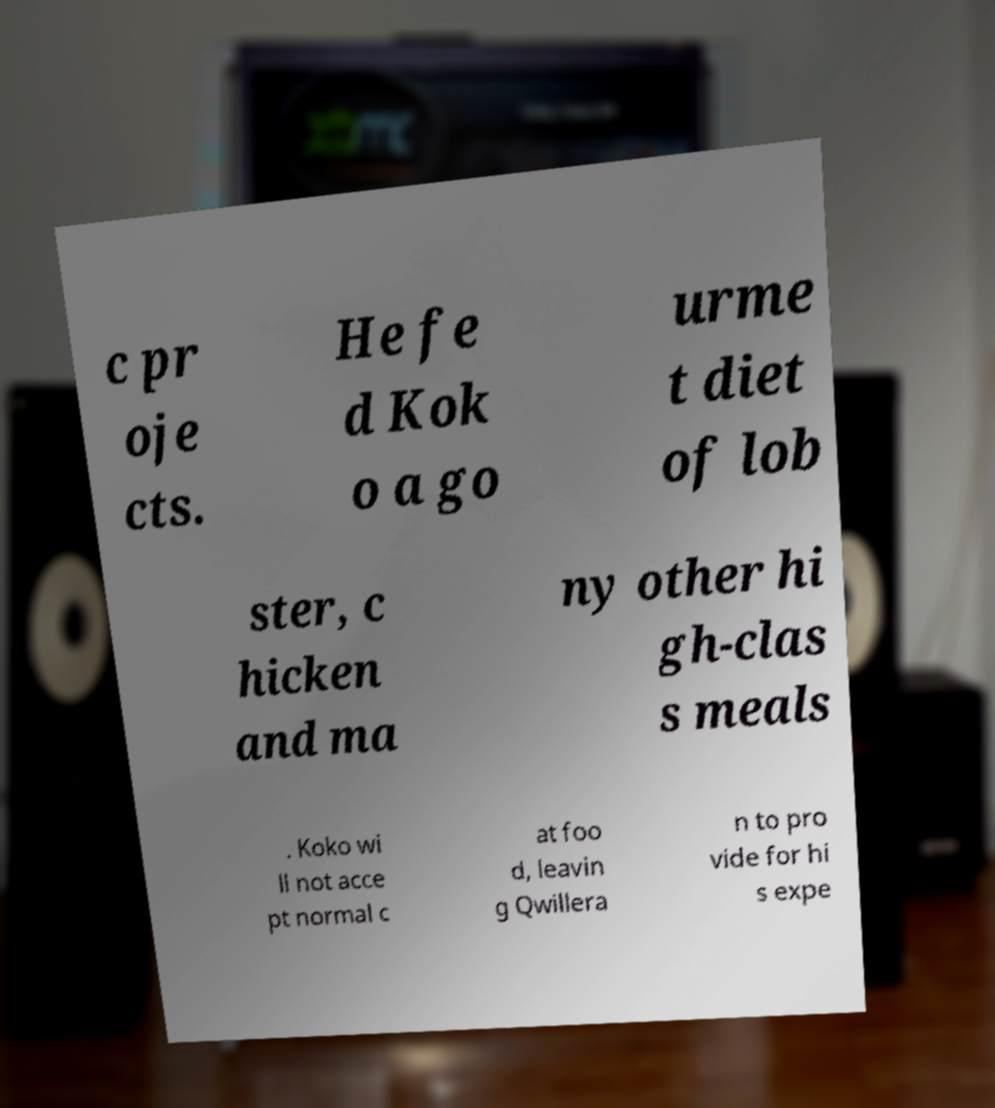Could you extract and type out the text from this image? c pr oje cts. He fe d Kok o a go urme t diet of lob ster, c hicken and ma ny other hi gh-clas s meals . Koko wi ll not acce pt normal c at foo d, leavin g Qwillera n to pro vide for hi s expe 